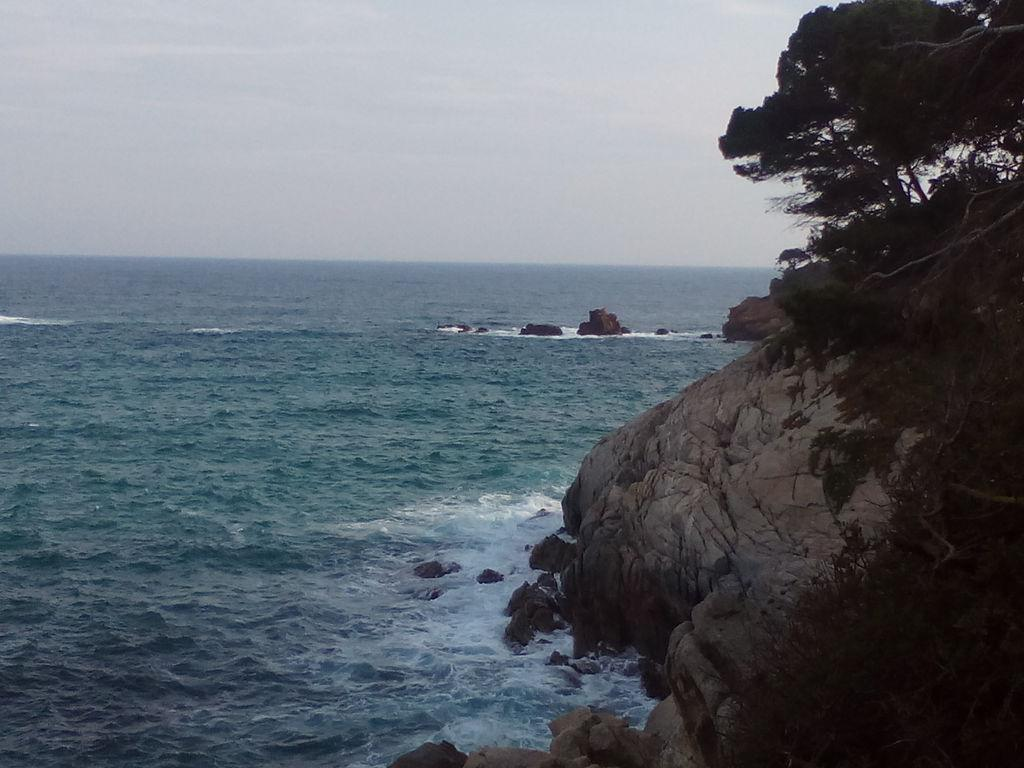What type of natural elements can be seen in the image? There are trees and rocks visible in the image. What else can be seen in the image besides the trees and rocks? There is water visible in the image. What is visible in the background of the image? The sky is visible in the image. How many events are taking place in the image? There is no event present in the image. 